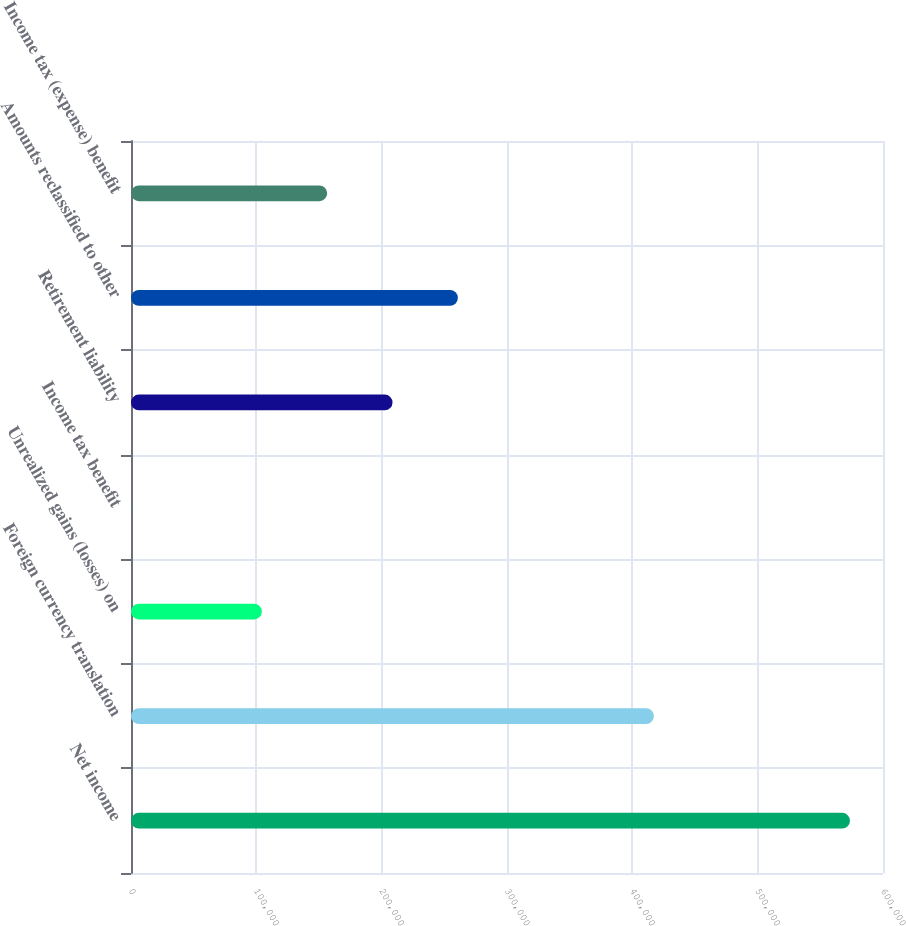Convert chart to OTSL. <chart><loc_0><loc_0><loc_500><loc_500><bar_chart><fcel>Net income<fcel>Foreign currency translation<fcel>Unrealized gains (losses) on<fcel>Income tax benefit<fcel>Retirement liability<fcel>Amounts reclassified to other<fcel>Income tax (expense) benefit<nl><fcel>573642<fcel>417225<fcel>104389<fcel>111<fcel>208668<fcel>260807<fcel>156529<nl></chart> 